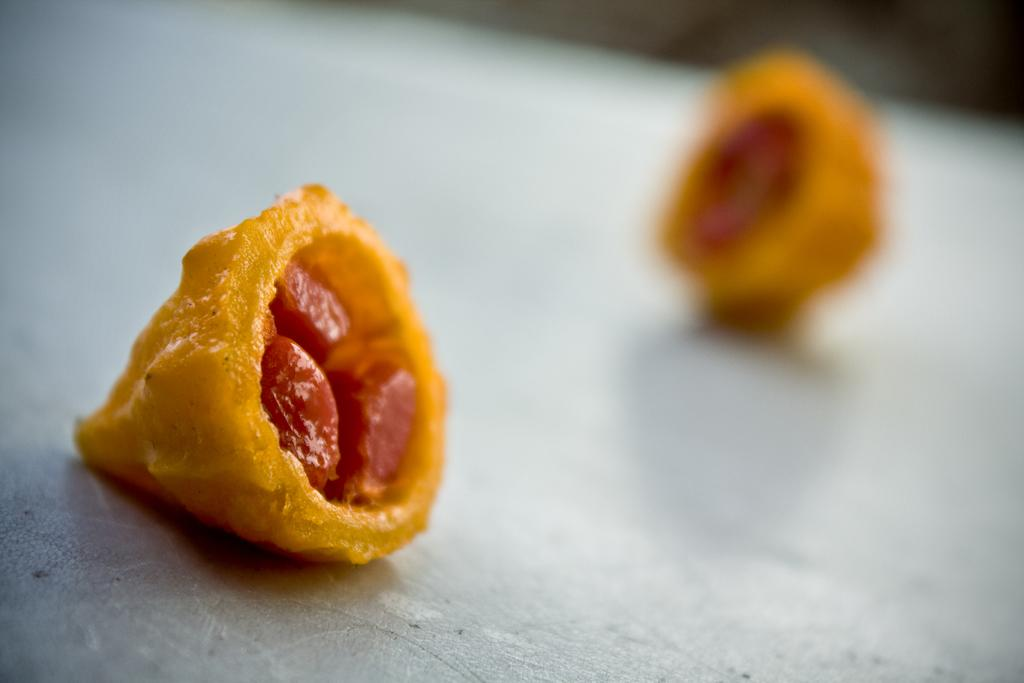What color are the food items in the image? The food items in the image are in yellow color. What type of education do the bears in the image have? There are no bears present in the image, and therefore no information about their education can be provided. 